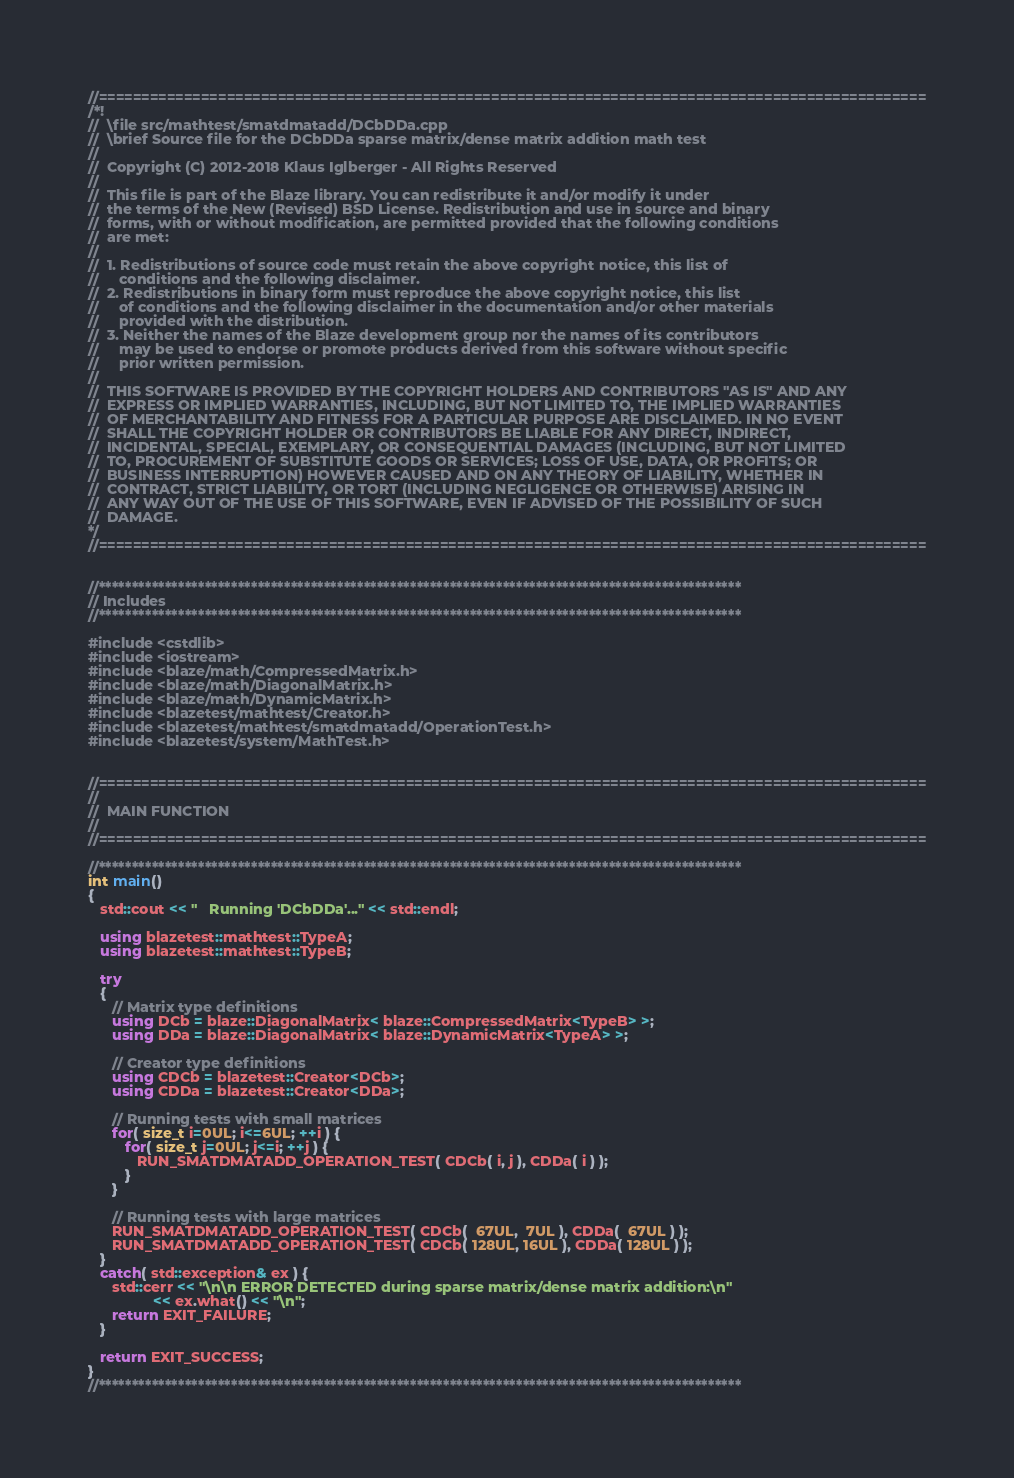<code> <loc_0><loc_0><loc_500><loc_500><_C++_>//=================================================================================================
/*!
//  \file src/mathtest/smatdmatadd/DCbDDa.cpp
//  \brief Source file for the DCbDDa sparse matrix/dense matrix addition math test
//
//  Copyright (C) 2012-2018 Klaus Iglberger - All Rights Reserved
//
//  This file is part of the Blaze library. You can redistribute it and/or modify it under
//  the terms of the New (Revised) BSD License. Redistribution and use in source and binary
//  forms, with or without modification, are permitted provided that the following conditions
//  are met:
//
//  1. Redistributions of source code must retain the above copyright notice, this list of
//     conditions and the following disclaimer.
//  2. Redistributions in binary form must reproduce the above copyright notice, this list
//     of conditions and the following disclaimer in the documentation and/or other materials
//     provided with the distribution.
//  3. Neither the names of the Blaze development group nor the names of its contributors
//     may be used to endorse or promote products derived from this software without specific
//     prior written permission.
//
//  THIS SOFTWARE IS PROVIDED BY THE COPYRIGHT HOLDERS AND CONTRIBUTORS "AS IS" AND ANY
//  EXPRESS OR IMPLIED WARRANTIES, INCLUDING, BUT NOT LIMITED TO, THE IMPLIED WARRANTIES
//  OF MERCHANTABILITY AND FITNESS FOR A PARTICULAR PURPOSE ARE DISCLAIMED. IN NO EVENT
//  SHALL THE COPYRIGHT HOLDER OR CONTRIBUTORS BE LIABLE FOR ANY DIRECT, INDIRECT,
//  INCIDENTAL, SPECIAL, EXEMPLARY, OR CONSEQUENTIAL DAMAGES (INCLUDING, BUT NOT LIMITED
//  TO, PROCUREMENT OF SUBSTITUTE GOODS OR SERVICES; LOSS OF USE, DATA, OR PROFITS; OR
//  BUSINESS INTERRUPTION) HOWEVER CAUSED AND ON ANY THEORY OF LIABILITY, WHETHER IN
//  CONTRACT, STRICT LIABILITY, OR TORT (INCLUDING NEGLIGENCE OR OTHERWISE) ARISING IN
//  ANY WAY OUT OF THE USE OF THIS SOFTWARE, EVEN IF ADVISED OF THE POSSIBILITY OF SUCH
//  DAMAGE.
*/
//=================================================================================================


//*************************************************************************************************
// Includes
//*************************************************************************************************

#include <cstdlib>
#include <iostream>
#include <blaze/math/CompressedMatrix.h>
#include <blaze/math/DiagonalMatrix.h>
#include <blaze/math/DynamicMatrix.h>
#include <blazetest/mathtest/Creator.h>
#include <blazetest/mathtest/smatdmatadd/OperationTest.h>
#include <blazetest/system/MathTest.h>


//=================================================================================================
//
//  MAIN FUNCTION
//
//=================================================================================================

//*************************************************************************************************
int main()
{
   std::cout << "   Running 'DCbDDa'..." << std::endl;

   using blazetest::mathtest::TypeA;
   using blazetest::mathtest::TypeB;

   try
   {
      // Matrix type definitions
      using DCb = blaze::DiagonalMatrix< blaze::CompressedMatrix<TypeB> >;
      using DDa = blaze::DiagonalMatrix< blaze::DynamicMatrix<TypeA> >;

      // Creator type definitions
      using CDCb = blazetest::Creator<DCb>;
      using CDDa = blazetest::Creator<DDa>;

      // Running tests with small matrices
      for( size_t i=0UL; i<=6UL; ++i ) {
         for( size_t j=0UL; j<=i; ++j ) {
            RUN_SMATDMATADD_OPERATION_TEST( CDCb( i, j ), CDDa( i ) );
         }
      }

      // Running tests with large matrices
      RUN_SMATDMATADD_OPERATION_TEST( CDCb(  67UL,  7UL ), CDDa(  67UL ) );
      RUN_SMATDMATADD_OPERATION_TEST( CDCb( 128UL, 16UL ), CDDa( 128UL ) );
   }
   catch( std::exception& ex ) {
      std::cerr << "\n\n ERROR DETECTED during sparse matrix/dense matrix addition:\n"
                << ex.what() << "\n";
      return EXIT_FAILURE;
   }

   return EXIT_SUCCESS;
}
//*************************************************************************************************
</code> 